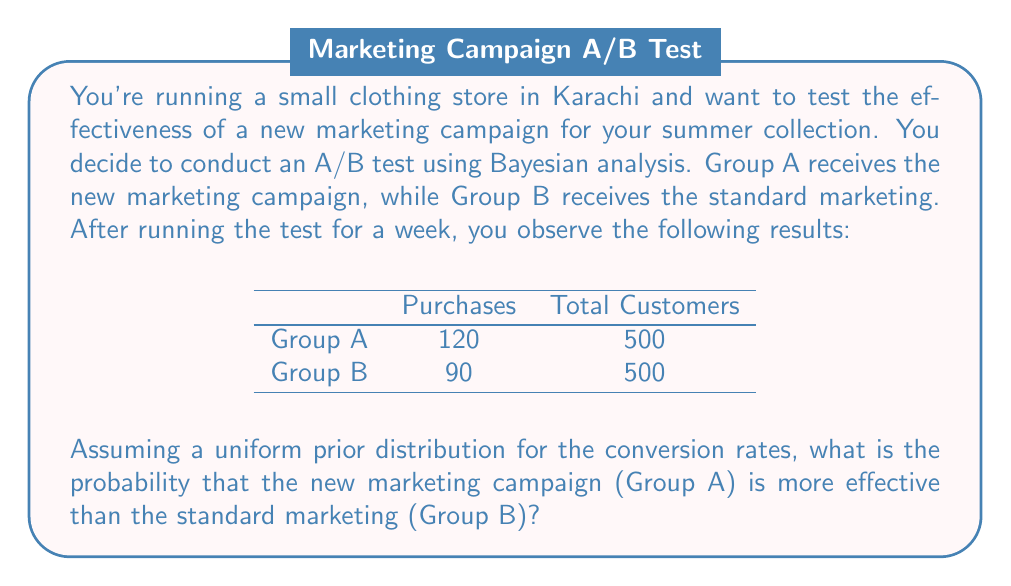Can you solve this math problem? To solve this problem using Bayesian analysis, we'll follow these steps:

1. Define the prior distributions
2. Update with the observed data to get posterior distributions
3. Calculate the probability that Group A's conversion rate is higher than Group B's

Step 1: Prior distributions
We assume uniform prior distributions for both groups:
$p_A, p_B \sim \text{Beta}(1, 1)$

Step 2: Posterior distributions
The posterior distribution for a Beta prior with Binomial likelihood is also a Beta distribution:
$\text{Posterior} \sim \text{Beta}(\alpha + \text{successes}, \beta + \text{failures})$

For Group A:
$p_A \sim \text{Beta}(1 + 120, 1 + 380) = \text{Beta}(121, 381)$

For Group B:
$p_B \sim \text{Beta}(1 + 90, 1 + 410) = \text{Beta}(91, 411)$

Step 3: Probability calculation
We need to calculate $P(p_A > p_B)$. This can be done using Monte Carlo simulation:

1. Generate a large number of samples (e.g., 100,000) from each posterior distribution.
2. Compare each pair of samples and count how often $p_A > p_B$.
3. Divide the count by the total number of samples to get the probability.

In Python, this would look like:

```python
import numpy as np

np.random.seed(0)
samples = 100000
p_a_samples = np.random.beta(121, 381, samples)
p_b_samples = np.random.beta(91, 411, samples)
prob_a_better = np.mean(p_a_samples > p_b_samples)
```

The result of this simulation gives us the probability that the new marketing campaign is more effective than the standard marketing.
Answer: $P(p_A > p_B) \approx 0.9992$ or 99.92%

This means there is a very high probability (approximately 99.92%) that the new marketing campaign (Group A) is more effective than the standard marketing (Group B), based on the observed data and assuming uniform prior distributions. 